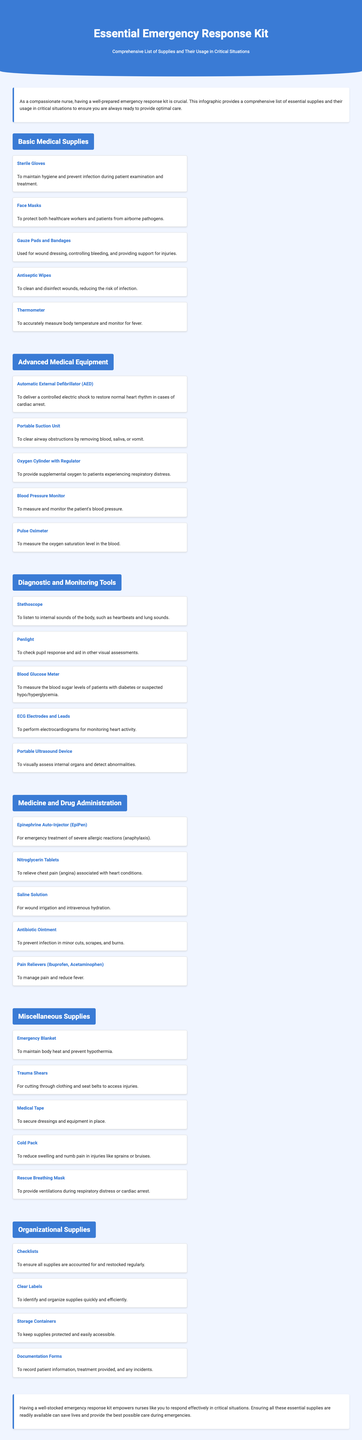what is the first item listed under Basic Medical Supplies? The first item listed under Basic Medical Supplies is Sterile Gloves.
Answer: Sterile Gloves how many sections are there in the document? The document contains a total of six sections.
Answer: six what is the purpose of an AED? The purpose of an AED is to deliver a controlled electric shock to restore normal heart rhythm in cases of cardiac arrest.
Answer: restore normal heart rhythm which supply is used to measure blood sugar levels? The supply used to measure blood sugar levels is a Blood Glucose Meter.
Answer: Blood Glucose Meter what is one item in the Miscellaneous Supplies section? One item in the Miscellaneous Supplies section is an Emergency Blanket.
Answer: Emergency Blanket why is it important to have clear labels? Clear labels are important to identify and organize supplies quickly and efficiently.
Answer: quickly and efficiently how often should the supplies be restocked? The document mentions using checklists to ensure all supplies are accounted for and restocked regularly.
Answer: regularly 